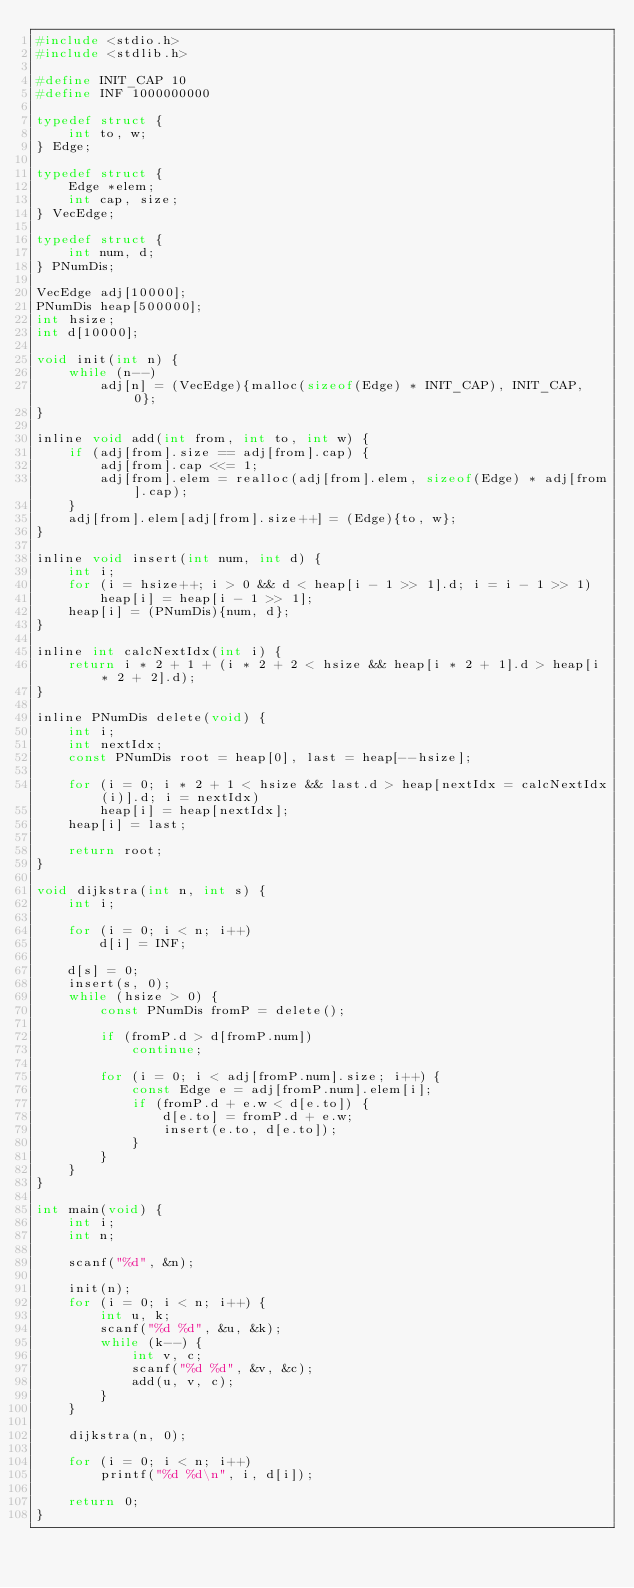<code> <loc_0><loc_0><loc_500><loc_500><_C_>#include <stdio.h>
#include <stdlib.h>

#define INIT_CAP 10
#define INF 1000000000

typedef struct {
	int to, w;
} Edge;

typedef struct {
	Edge *elem;
	int cap, size;
} VecEdge;

typedef struct {
	int num, d;
} PNumDis;

VecEdge adj[10000];
PNumDis heap[500000];
int hsize;
int d[10000];

void init(int n) {
	while (n--)
		adj[n] = (VecEdge){malloc(sizeof(Edge) * INIT_CAP), INIT_CAP, 0};
}

inline void add(int from, int to, int w) {
	if (adj[from].size == adj[from].cap) {
		adj[from].cap <<= 1;
		adj[from].elem = realloc(adj[from].elem, sizeof(Edge) * adj[from].cap);
	}
	adj[from].elem[adj[from].size++] = (Edge){to, w};
}

inline void insert(int num, int d) {
	int i;
	for (i = hsize++; i > 0 && d < heap[i - 1 >> 1].d; i = i - 1 >> 1)
		heap[i] = heap[i - 1 >> 1];
	heap[i] = (PNumDis){num, d};
}

inline int calcNextIdx(int i) {
	return i * 2 + 1 + (i * 2 + 2 < hsize && heap[i * 2 + 1].d > heap[i * 2 + 2].d);
}

inline PNumDis delete(void) {
	int i;
	int nextIdx;
	const PNumDis root = heap[0], last = heap[--hsize];

	for (i = 0; i * 2 + 1 < hsize && last.d > heap[nextIdx = calcNextIdx(i)].d; i = nextIdx)
		heap[i] = heap[nextIdx];
	heap[i] = last;

	return root;
}

void dijkstra(int n, int s) {
	int i;

	for (i = 0; i < n; i++)
		d[i] = INF;

	d[s] = 0;
	insert(s, 0);
	while (hsize > 0) {
		const PNumDis fromP = delete();

		if (fromP.d > d[fromP.num])
			continue;

		for (i = 0; i < adj[fromP.num].size; i++) {
			const Edge e = adj[fromP.num].elem[i];
			if (fromP.d + e.w < d[e.to]) {
				d[e.to] = fromP.d + e.w;
				insert(e.to, d[e.to]);
			}
		}
	}
}

int main(void) {
	int i;
	int n;

	scanf("%d", &n);

	init(n);
	for (i = 0; i < n; i++) {
		int u, k;
		scanf("%d %d", &u, &k);
		while (k--) {
			int v, c;
			scanf("%d %d", &v, &c);
			add(u, v, c);
		}
	}

	dijkstra(n, 0);

	for (i = 0; i < n; i++)
		printf("%d %d\n", i, d[i]);

	return 0;
}</code> 